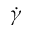Convert formula to latex. <formula><loc_0><loc_0><loc_500><loc_500>\dot { \gamma }</formula> 